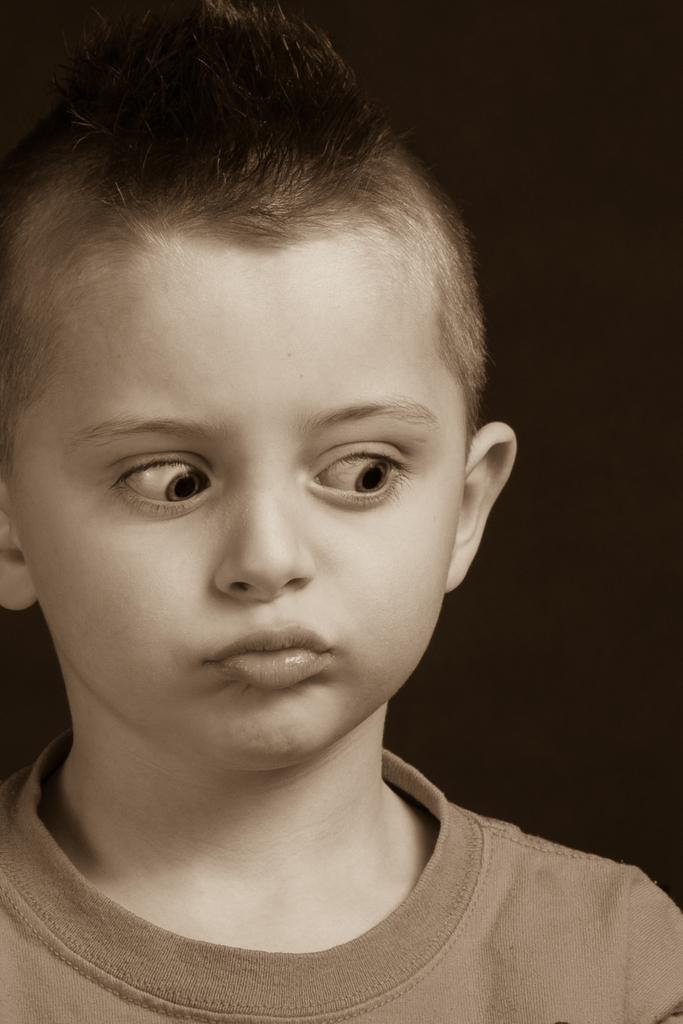What is the color scheme of the image? The image is black and white. Who is present in the image? There is a boy in the image. What can be seen in the background of the image? The background of the image is dark. Where is the library located in the image? There is no library present in the image. What type of touch can be seen in the image? There is no specific touch or action visible in the image; it is a still photograph. 